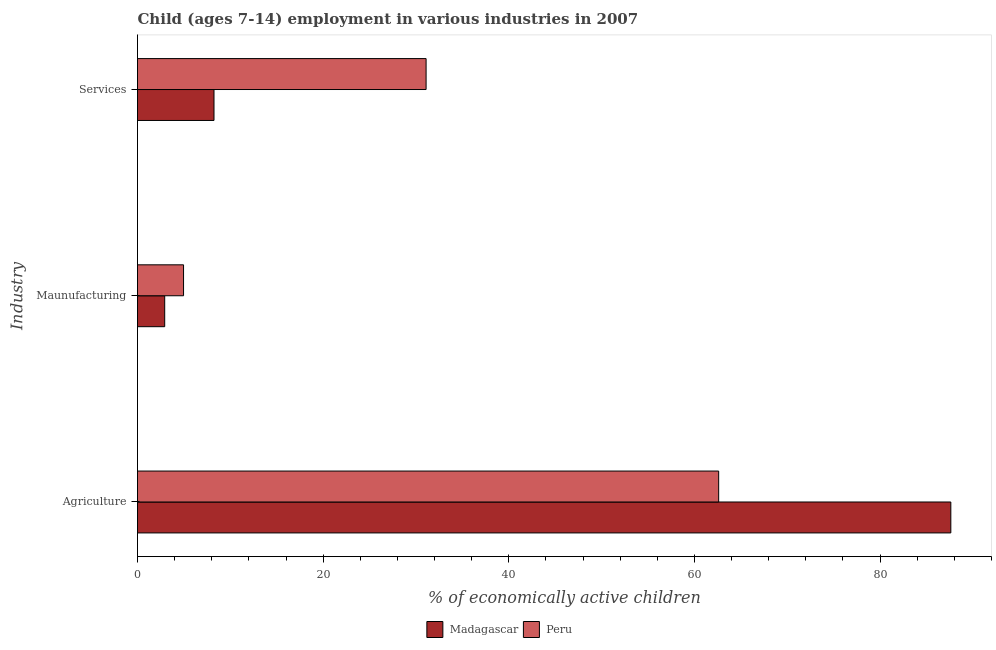How many different coloured bars are there?
Provide a succinct answer. 2. How many groups of bars are there?
Your answer should be very brief. 3. How many bars are there on the 2nd tick from the top?
Provide a succinct answer. 2. How many bars are there on the 2nd tick from the bottom?
Offer a very short reply. 2. What is the label of the 1st group of bars from the top?
Your response must be concise. Services. What is the percentage of economically active children in services in Madagascar?
Keep it short and to the point. 8.24. Across all countries, what is the maximum percentage of economically active children in agriculture?
Your answer should be compact. 87.62. Across all countries, what is the minimum percentage of economically active children in services?
Provide a succinct answer. 8.24. In which country was the percentage of economically active children in manufacturing maximum?
Your answer should be very brief. Peru. In which country was the percentage of economically active children in services minimum?
Offer a terse response. Madagascar. What is the total percentage of economically active children in services in the graph?
Ensure brevity in your answer.  39.33. What is the difference between the percentage of economically active children in agriculture in Madagascar and that in Peru?
Your answer should be very brief. 25.01. What is the difference between the percentage of economically active children in services in Peru and the percentage of economically active children in agriculture in Madagascar?
Offer a very short reply. -56.53. What is the average percentage of economically active children in services per country?
Keep it short and to the point. 19.66. What is the difference between the percentage of economically active children in manufacturing and percentage of economically active children in agriculture in Madagascar?
Offer a terse response. -84.69. In how many countries, is the percentage of economically active children in agriculture greater than 12 %?
Offer a very short reply. 2. What is the ratio of the percentage of economically active children in services in Peru to that in Madagascar?
Provide a succinct answer. 3.77. Is the percentage of economically active children in agriculture in Peru less than that in Madagascar?
Offer a very short reply. Yes. Is the difference between the percentage of economically active children in services in Madagascar and Peru greater than the difference between the percentage of economically active children in manufacturing in Madagascar and Peru?
Your answer should be compact. No. What is the difference between the highest and the second highest percentage of economically active children in agriculture?
Your answer should be compact. 25.01. What is the difference between the highest and the lowest percentage of economically active children in manufacturing?
Provide a succinct answer. 2.03. In how many countries, is the percentage of economically active children in agriculture greater than the average percentage of economically active children in agriculture taken over all countries?
Keep it short and to the point. 1. What does the 2nd bar from the top in Agriculture represents?
Make the answer very short. Madagascar. Is it the case that in every country, the sum of the percentage of economically active children in agriculture and percentage of economically active children in manufacturing is greater than the percentage of economically active children in services?
Your response must be concise. Yes. How many bars are there?
Your response must be concise. 6. Are all the bars in the graph horizontal?
Your answer should be compact. Yes. How many countries are there in the graph?
Offer a very short reply. 2. Are the values on the major ticks of X-axis written in scientific E-notation?
Offer a very short reply. No. Does the graph contain any zero values?
Your response must be concise. No. Does the graph contain grids?
Offer a terse response. No. What is the title of the graph?
Make the answer very short. Child (ages 7-14) employment in various industries in 2007. What is the label or title of the X-axis?
Offer a terse response. % of economically active children. What is the label or title of the Y-axis?
Provide a short and direct response. Industry. What is the % of economically active children of Madagascar in Agriculture?
Make the answer very short. 87.62. What is the % of economically active children in Peru in Agriculture?
Provide a short and direct response. 62.61. What is the % of economically active children in Madagascar in Maunufacturing?
Offer a terse response. 2.93. What is the % of economically active children in Peru in Maunufacturing?
Your answer should be very brief. 4.96. What is the % of economically active children in Madagascar in Services?
Your response must be concise. 8.24. What is the % of economically active children of Peru in Services?
Your response must be concise. 31.09. Across all Industry, what is the maximum % of economically active children of Madagascar?
Provide a short and direct response. 87.62. Across all Industry, what is the maximum % of economically active children in Peru?
Provide a succinct answer. 62.61. Across all Industry, what is the minimum % of economically active children of Madagascar?
Offer a very short reply. 2.93. Across all Industry, what is the minimum % of economically active children in Peru?
Offer a terse response. 4.96. What is the total % of economically active children of Madagascar in the graph?
Give a very brief answer. 98.79. What is the total % of economically active children of Peru in the graph?
Your response must be concise. 98.66. What is the difference between the % of economically active children of Madagascar in Agriculture and that in Maunufacturing?
Ensure brevity in your answer.  84.69. What is the difference between the % of economically active children of Peru in Agriculture and that in Maunufacturing?
Your response must be concise. 57.65. What is the difference between the % of economically active children in Madagascar in Agriculture and that in Services?
Offer a terse response. 79.38. What is the difference between the % of economically active children of Peru in Agriculture and that in Services?
Ensure brevity in your answer.  31.52. What is the difference between the % of economically active children of Madagascar in Maunufacturing and that in Services?
Ensure brevity in your answer.  -5.31. What is the difference between the % of economically active children of Peru in Maunufacturing and that in Services?
Your response must be concise. -26.13. What is the difference between the % of economically active children in Madagascar in Agriculture and the % of economically active children in Peru in Maunufacturing?
Offer a very short reply. 82.66. What is the difference between the % of economically active children of Madagascar in Agriculture and the % of economically active children of Peru in Services?
Provide a succinct answer. 56.53. What is the difference between the % of economically active children in Madagascar in Maunufacturing and the % of economically active children in Peru in Services?
Give a very brief answer. -28.16. What is the average % of economically active children in Madagascar per Industry?
Offer a terse response. 32.93. What is the average % of economically active children of Peru per Industry?
Ensure brevity in your answer.  32.89. What is the difference between the % of economically active children of Madagascar and % of economically active children of Peru in Agriculture?
Your response must be concise. 25.01. What is the difference between the % of economically active children in Madagascar and % of economically active children in Peru in Maunufacturing?
Provide a short and direct response. -2.03. What is the difference between the % of economically active children in Madagascar and % of economically active children in Peru in Services?
Keep it short and to the point. -22.85. What is the ratio of the % of economically active children of Madagascar in Agriculture to that in Maunufacturing?
Your answer should be very brief. 29.9. What is the ratio of the % of economically active children of Peru in Agriculture to that in Maunufacturing?
Your answer should be very brief. 12.62. What is the ratio of the % of economically active children of Madagascar in Agriculture to that in Services?
Give a very brief answer. 10.63. What is the ratio of the % of economically active children of Peru in Agriculture to that in Services?
Make the answer very short. 2.01. What is the ratio of the % of economically active children of Madagascar in Maunufacturing to that in Services?
Offer a terse response. 0.36. What is the ratio of the % of economically active children of Peru in Maunufacturing to that in Services?
Your answer should be very brief. 0.16. What is the difference between the highest and the second highest % of economically active children in Madagascar?
Ensure brevity in your answer.  79.38. What is the difference between the highest and the second highest % of economically active children in Peru?
Ensure brevity in your answer.  31.52. What is the difference between the highest and the lowest % of economically active children in Madagascar?
Make the answer very short. 84.69. What is the difference between the highest and the lowest % of economically active children of Peru?
Make the answer very short. 57.65. 